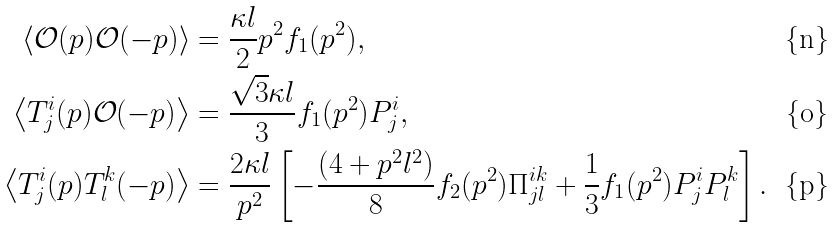Convert formula to latex. <formula><loc_0><loc_0><loc_500><loc_500>\left \langle \mathcal { O } ( p ) \mathcal { O } ( - p ) \right \rangle & = \frac { \kappa l } 2 p ^ { 2 } f _ { 1 } ( p ^ { 2 } ) , \\ \left \langle T ^ { i } _ { j } ( p ) \mathcal { O } ( - p ) \right \rangle & = \frac { \sqrt { 3 } \kappa l } 3 f _ { 1 } ( p ^ { 2 } ) P ^ { i } _ { j } , \\ \left \langle T ^ { i } _ { j } ( p ) T ^ { k } _ { l } ( - p ) \right \rangle & = \frac { 2 \kappa l } { p ^ { 2 } } \left [ - \frac { ( 4 + p ^ { 2 } l ^ { 2 } ) } 8 f _ { 2 } ( p ^ { 2 } ) \Pi ^ { i k } _ { j l } + \frac { 1 } { 3 } f _ { 1 } ( p ^ { 2 } ) P ^ { i } _ { j } P ^ { k } _ { l } \right ] .</formula> 